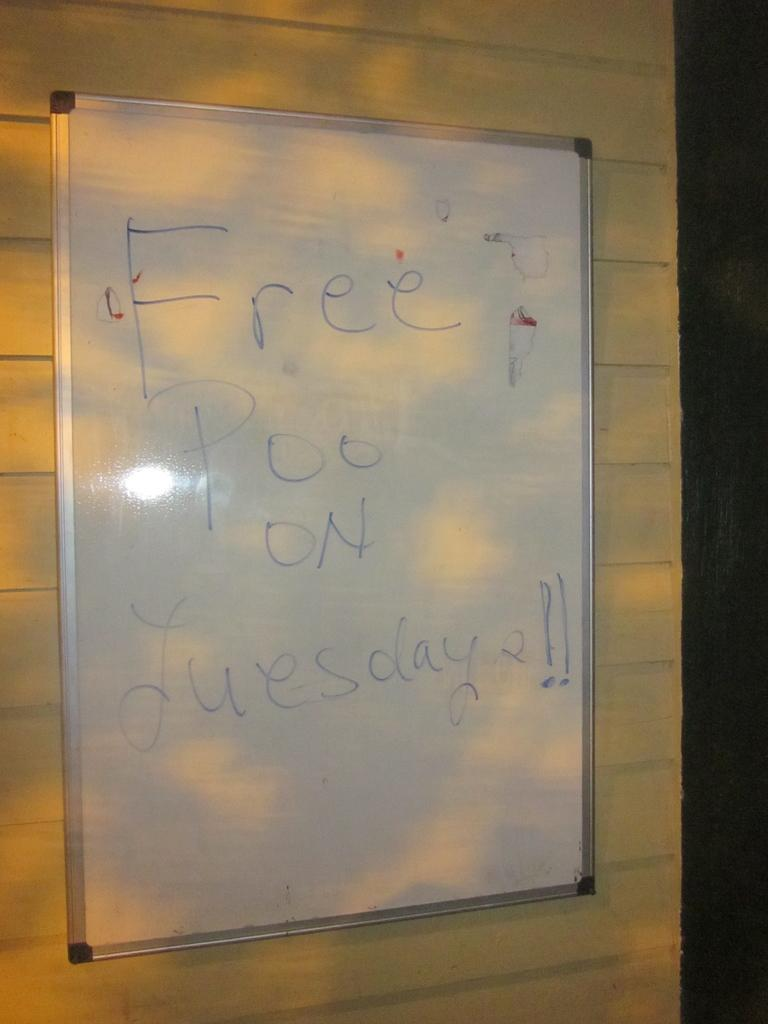<image>
Offer a succinct explanation of the picture presented. Someone has written "free poo on Tuesday" on a white board. 